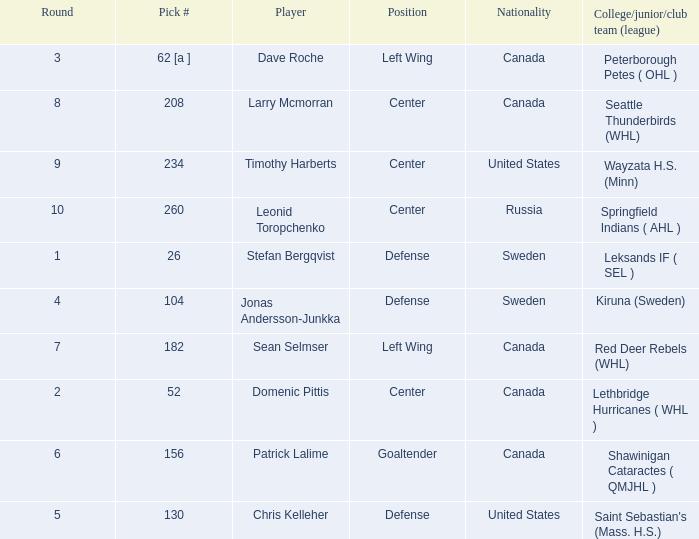What is the nationality of the player whose college/junior/club team (league) is Seattle Thunderbirds (WHL)? Canada. 